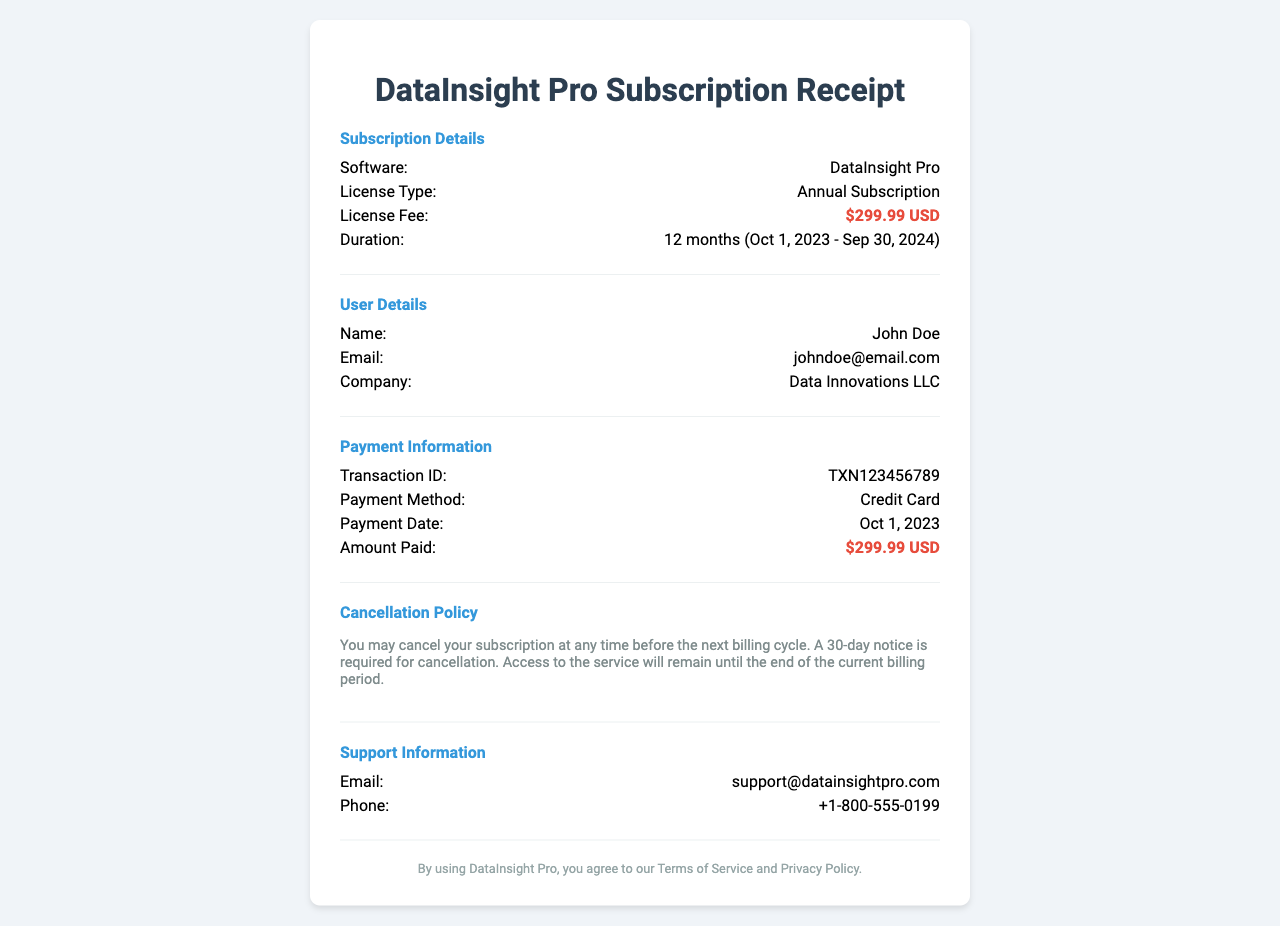What is the software name? The software name is explicitly stated in the receipt under "Subscription Details."
Answer: DataInsight Pro What is the license fee? The license fee is highlighted in the "Subscription Details" section of the receipt.
Answer: $299.99 USD What is the subscription duration? The duration is specified in the "Subscription Details" section, mentioning the start and end dates.
Answer: 12 months (Oct 1, 2023 - Sep 30, 2024) What is the transaction ID? The transaction ID is provided in the "Payment Information" section and is essential for payment tracking.
Answer: TXN123456789 What is the cancellation notice required? The cancellation policy outlines the required notice period for cancellation in the provided text.
Answer: 30-day notice Who is the user? The user is mentioned in the "User Details" section, providing personal identification.
Answer: John Doe What is the payment method? The payment method is listed under "Payment Information," indicating how the user settled their payment.
Answer: Credit Card When was the payment made? The payment date is also found in the "Payment Information" section, reflecting when the transaction occurred.
Answer: Oct 1, 2023 What type of subscription is this? The type of subscription is stated in the "Subscription Details" section, describing the user's commitment.
Answer: Annual Subscription 